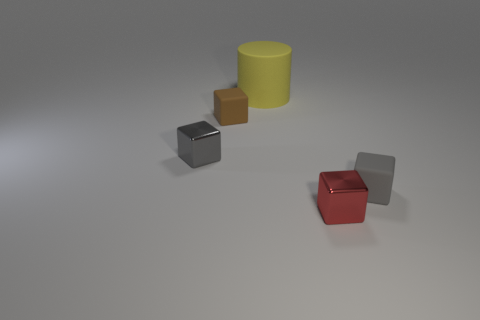Subtract all small gray rubber blocks. How many blocks are left? 3 Subtract all gray cubes. How many cubes are left? 2 Add 5 yellow shiny cylinders. How many objects exist? 10 Subtract 1 cylinders. How many cylinders are left? 0 Subtract all cylinders. How many objects are left? 4 Subtract all gray cylinders. How many gray blocks are left? 2 Subtract all big spheres. Subtract all tiny gray shiny cubes. How many objects are left? 4 Add 5 tiny shiny things. How many tiny shiny things are left? 7 Add 3 red objects. How many red objects exist? 4 Subtract 0 purple blocks. How many objects are left? 5 